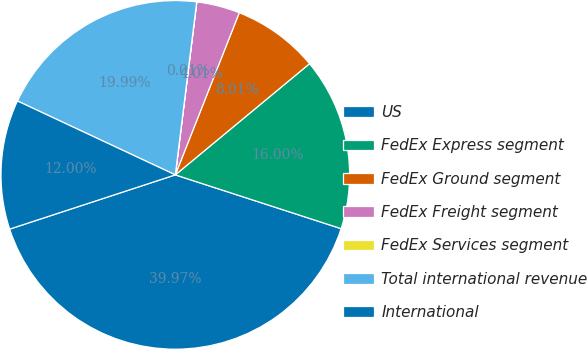<chart> <loc_0><loc_0><loc_500><loc_500><pie_chart><fcel>US<fcel>FedEx Express segment<fcel>FedEx Ground segment<fcel>FedEx Freight segment<fcel>FedEx Services segment<fcel>Total international revenue<fcel>International<nl><fcel>39.97%<fcel>16.0%<fcel>8.01%<fcel>4.01%<fcel>0.01%<fcel>19.99%<fcel>12.0%<nl></chart> 